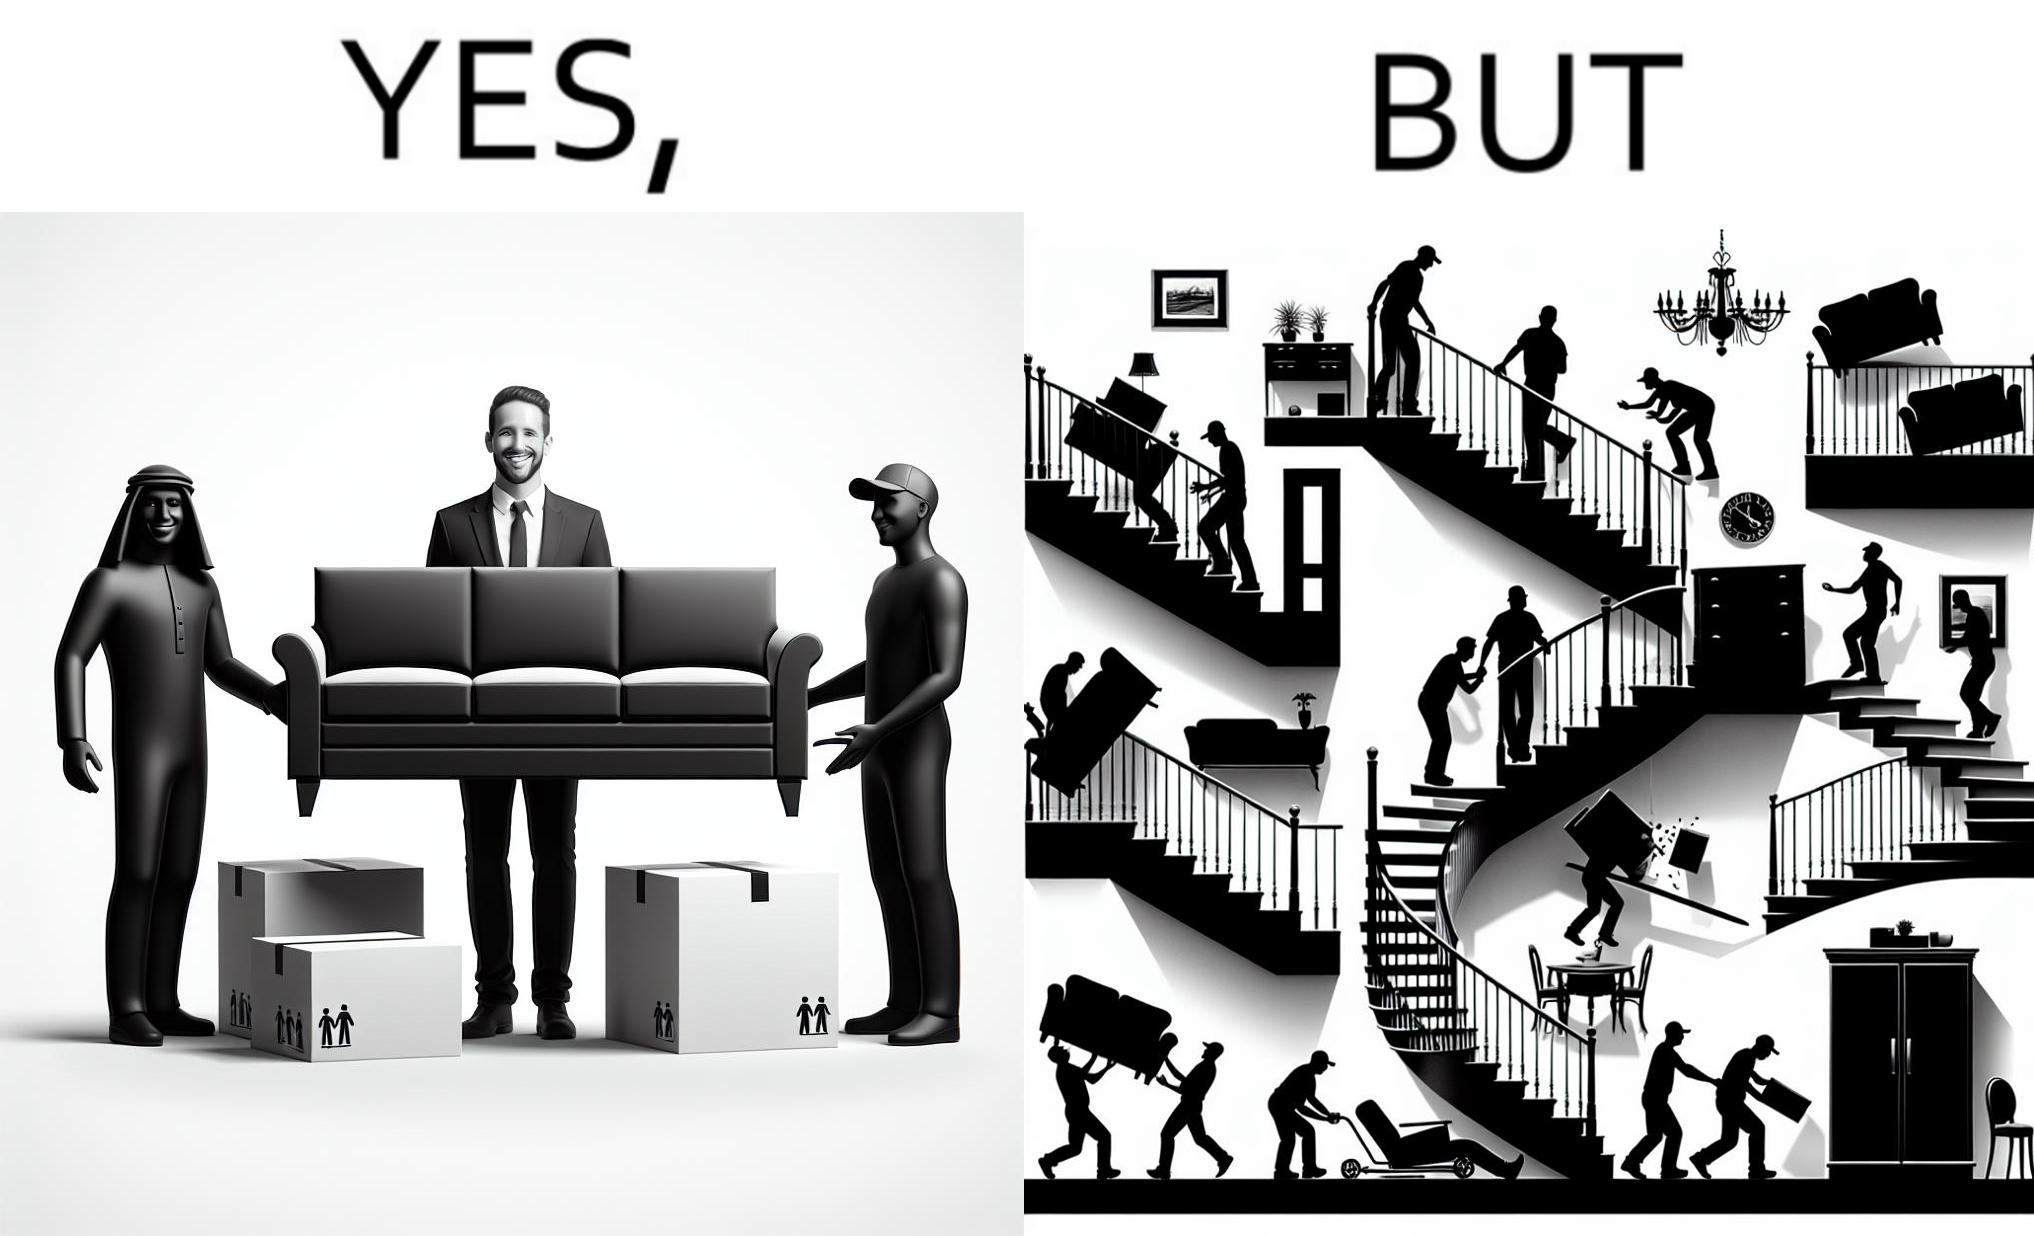What does this image depict? The images are funny since they show how even though the hired movers achieve their task of moving in furniture, in the process, the cause damage to the whole house 